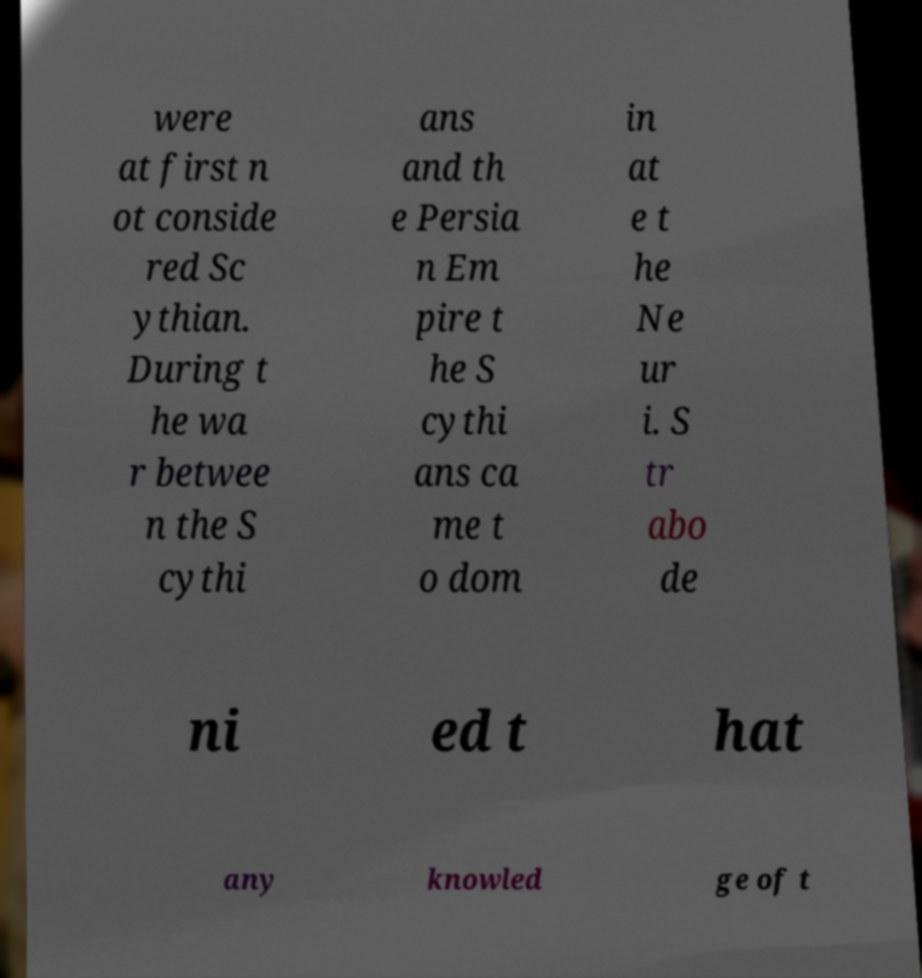Can you accurately transcribe the text from the provided image for me? were at first n ot conside red Sc ythian. During t he wa r betwee n the S cythi ans and th e Persia n Em pire t he S cythi ans ca me t o dom in at e t he Ne ur i. S tr abo de ni ed t hat any knowled ge of t 